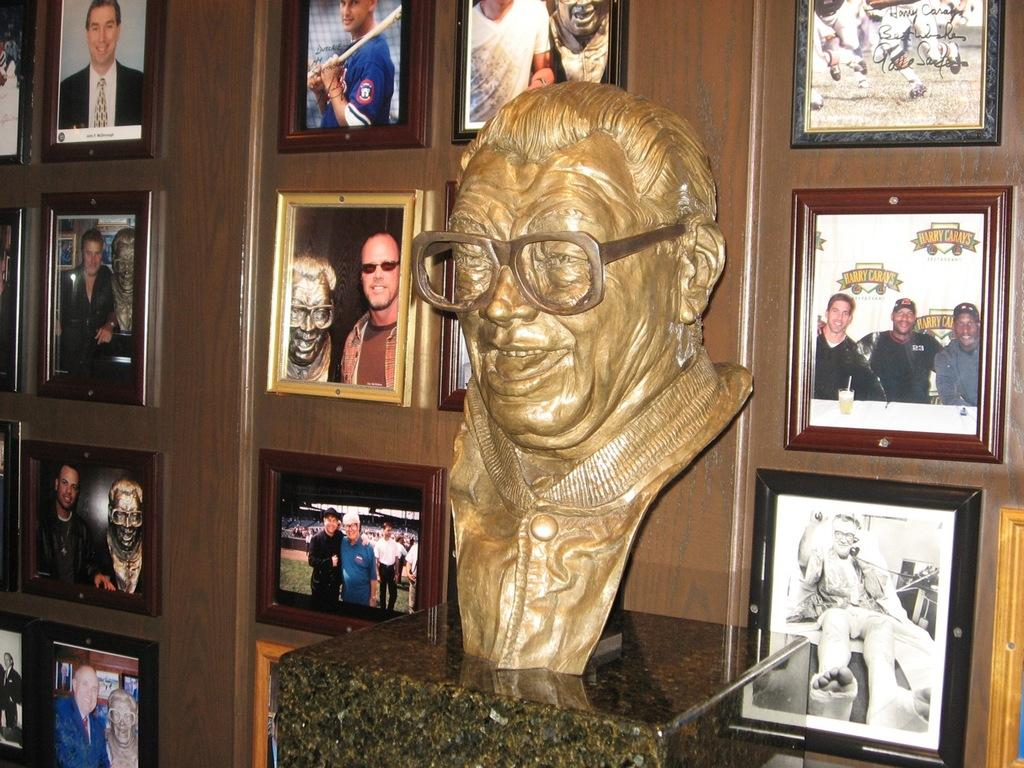What is the main subject of the image? The main subject of the image is a sculpture on the surface of stone. Are there any other objects or elements in the image? Yes, photographs are attached to the wall behind the sculpture. What type of company is conducting a skate event at the cemetery in the image? There is no company, skate event, or cemetery present in the image; it only features a sculpture on the surface of stone and photographs attached to the wall. 